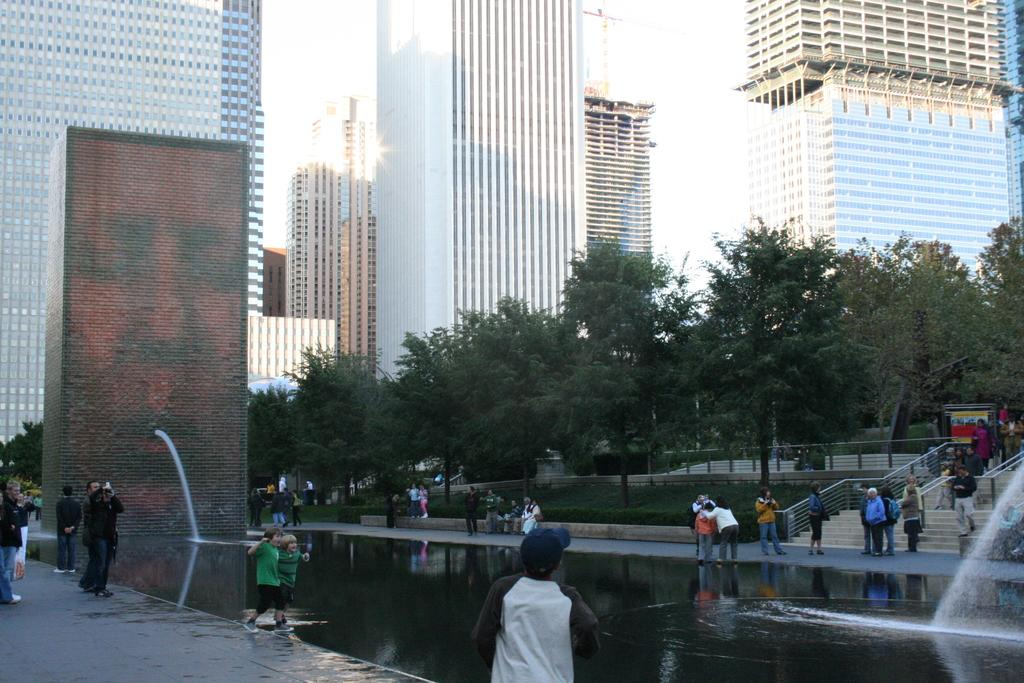What is the main feature in the center of the image? There are fountains in the center of the image. What can be seen in the background of the image? There are people, trees, buildings, and stairs in the background of the image. What type of cream is being used to paint the middle of the image? There is no cream or painting activity present in the image; it features fountains in the center. 